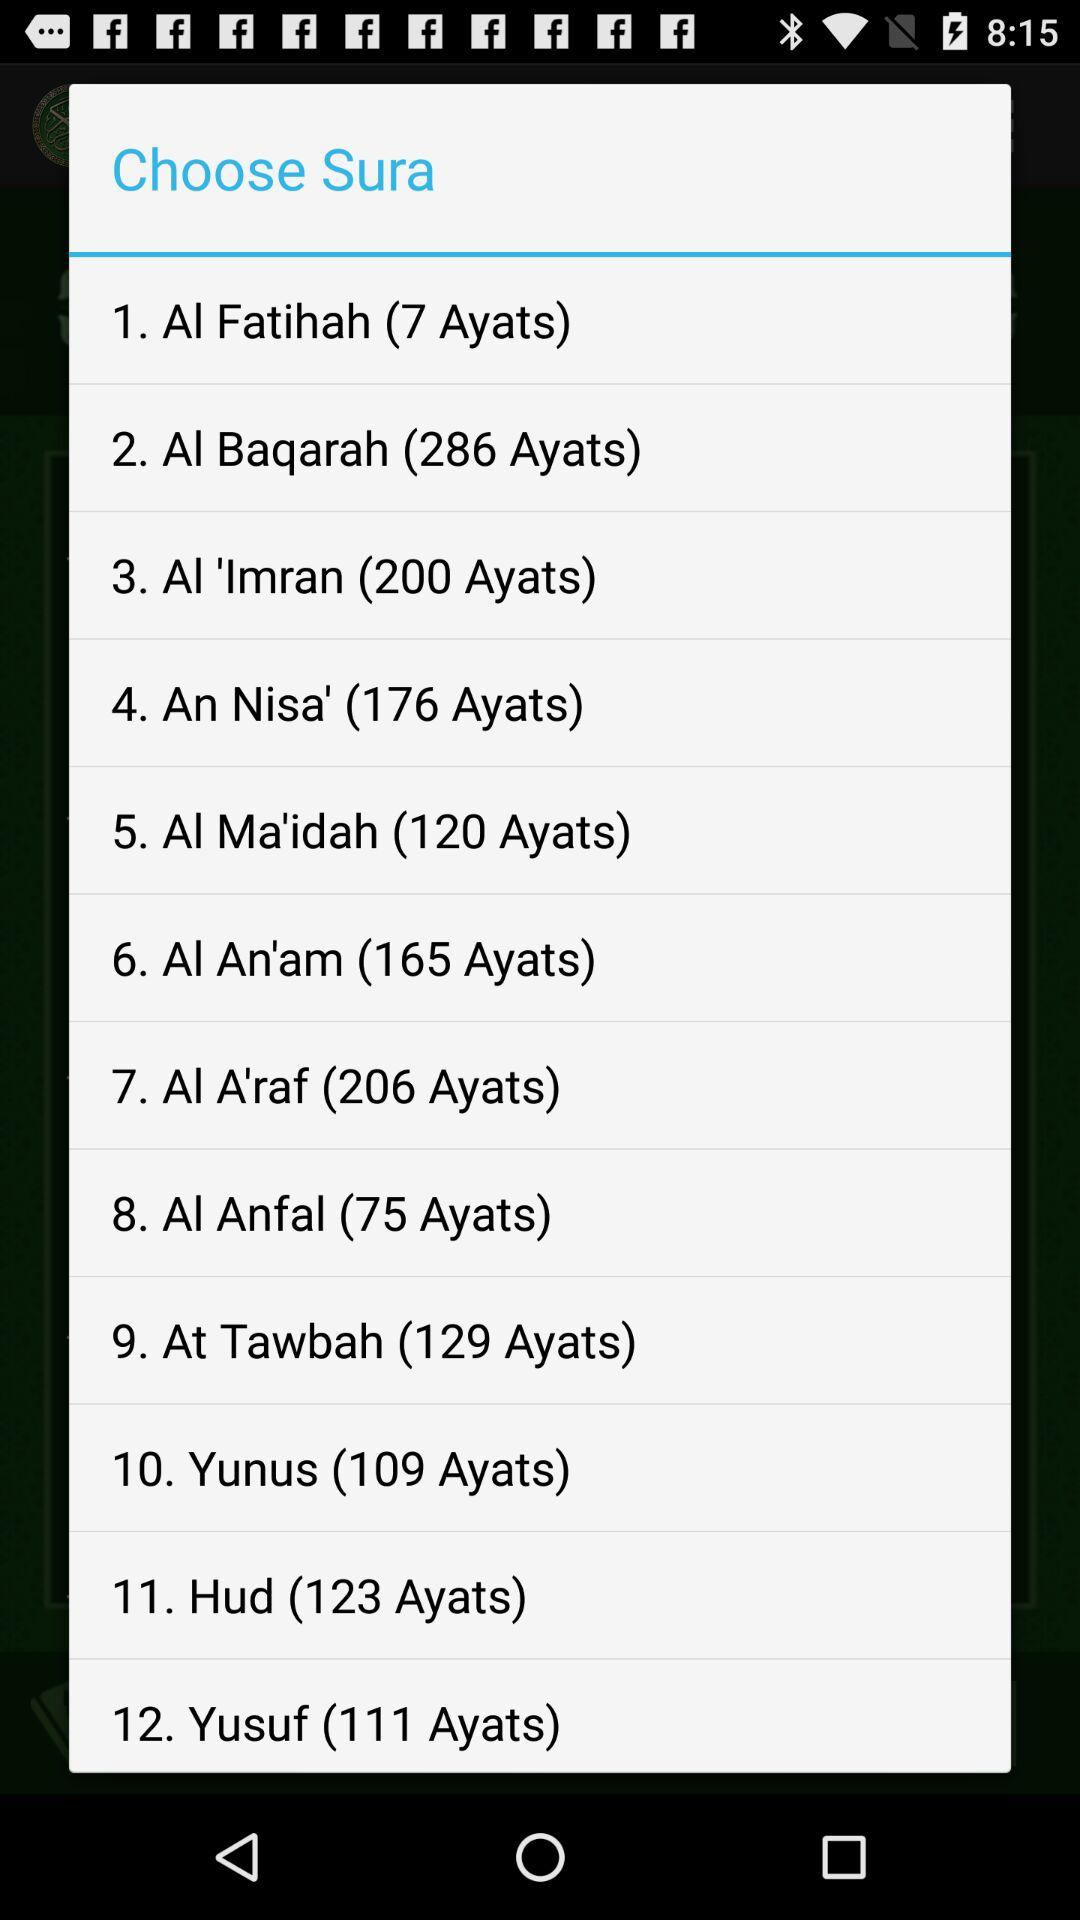How many ayats are in the shortest sura?
Answer the question using a single word or phrase. 7 